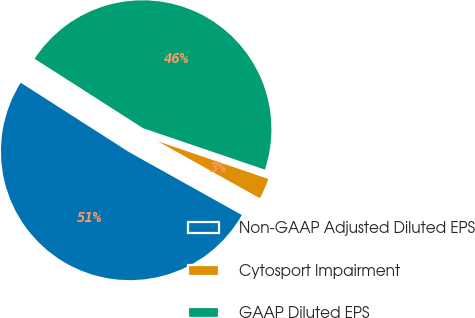<chart> <loc_0><loc_0><loc_500><loc_500><pie_chart><fcel>Non-GAAP Adjusted Diluted EPS<fcel>Cytosport Impairment<fcel>GAAP Diluted EPS<nl><fcel>50.96%<fcel>2.88%<fcel>46.15%<nl></chart> 